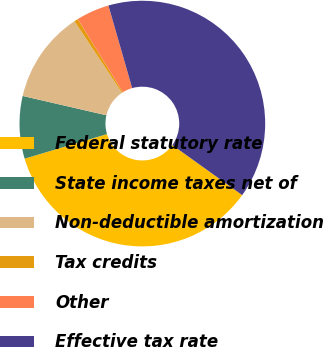Convert chart to OTSL. <chart><loc_0><loc_0><loc_500><loc_500><pie_chart><fcel>Federal statutory rate<fcel>State income taxes net of<fcel>Non-deductible amortization<fcel>Tax credits<fcel>Other<fcel>Effective tax rate<nl><fcel>35.5%<fcel>8.22%<fcel>12.07%<fcel>0.51%<fcel>4.36%<fcel>39.35%<nl></chart> 